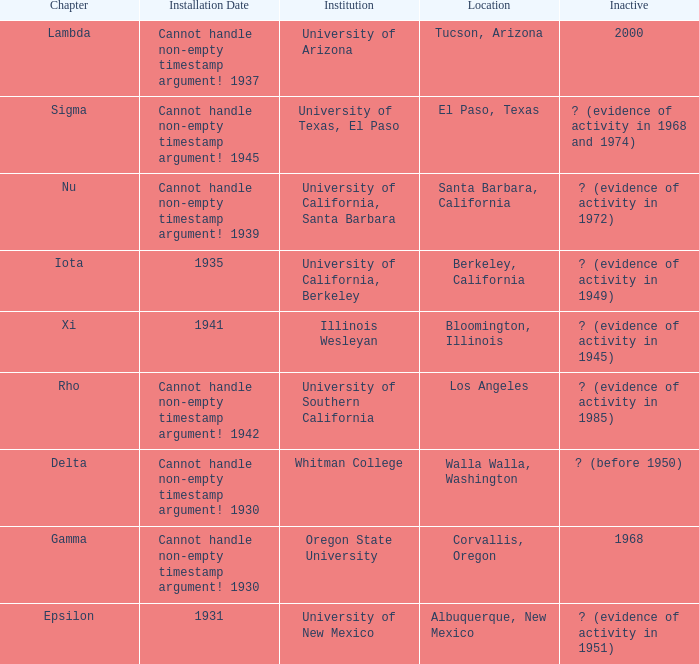What is the chapter for Illinois Wesleyan?  Xi. 